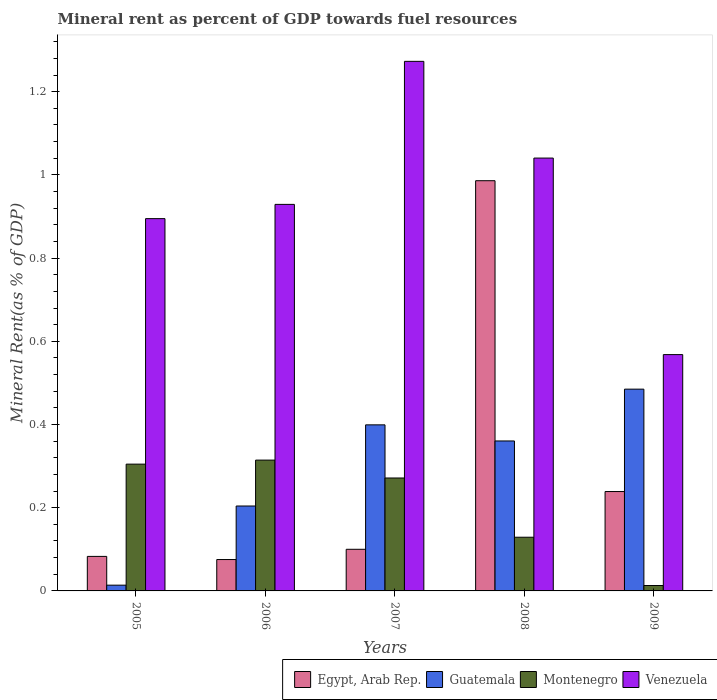How many different coloured bars are there?
Offer a very short reply. 4. Are the number of bars per tick equal to the number of legend labels?
Your answer should be compact. Yes. How many bars are there on the 2nd tick from the left?
Your answer should be very brief. 4. How many bars are there on the 3rd tick from the right?
Your response must be concise. 4. In how many cases, is the number of bars for a given year not equal to the number of legend labels?
Offer a very short reply. 0. What is the mineral rent in Guatemala in 2005?
Your answer should be compact. 0.01. Across all years, what is the maximum mineral rent in Egypt, Arab Rep.?
Ensure brevity in your answer.  0.99. Across all years, what is the minimum mineral rent in Egypt, Arab Rep.?
Provide a succinct answer. 0.08. In which year was the mineral rent in Egypt, Arab Rep. maximum?
Your response must be concise. 2008. What is the total mineral rent in Venezuela in the graph?
Ensure brevity in your answer.  4.71. What is the difference between the mineral rent in Montenegro in 2006 and that in 2008?
Offer a terse response. 0.19. What is the difference between the mineral rent in Guatemala in 2007 and the mineral rent in Montenegro in 2005?
Offer a very short reply. 0.09. What is the average mineral rent in Egypt, Arab Rep. per year?
Your response must be concise. 0.3. In the year 2007, what is the difference between the mineral rent in Guatemala and mineral rent in Venezuela?
Make the answer very short. -0.87. In how many years, is the mineral rent in Venezuela greater than 1 %?
Provide a short and direct response. 2. What is the ratio of the mineral rent in Montenegro in 2008 to that in 2009?
Ensure brevity in your answer.  9.93. Is the mineral rent in Venezuela in 2007 less than that in 2008?
Offer a terse response. No. What is the difference between the highest and the second highest mineral rent in Egypt, Arab Rep.?
Keep it short and to the point. 0.75. What is the difference between the highest and the lowest mineral rent in Montenegro?
Give a very brief answer. 0.3. Is the sum of the mineral rent in Egypt, Arab Rep. in 2007 and 2009 greater than the maximum mineral rent in Montenegro across all years?
Your response must be concise. Yes. What does the 2nd bar from the left in 2008 represents?
Provide a short and direct response. Guatemala. What does the 1st bar from the right in 2005 represents?
Ensure brevity in your answer.  Venezuela. Is it the case that in every year, the sum of the mineral rent in Montenegro and mineral rent in Venezuela is greater than the mineral rent in Guatemala?
Offer a terse response. Yes. How many bars are there?
Offer a terse response. 20. Are all the bars in the graph horizontal?
Offer a very short reply. No. What is the difference between two consecutive major ticks on the Y-axis?
Provide a short and direct response. 0.2. Does the graph contain grids?
Offer a terse response. No. How many legend labels are there?
Your answer should be very brief. 4. How are the legend labels stacked?
Give a very brief answer. Horizontal. What is the title of the graph?
Your answer should be very brief. Mineral rent as percent of GDP towards fuel resources. Does "Sub-Saharan Africa (all income levels)" appear as one of the legend labels in the graph?
Your answer should be very brief. No. What is the label or title of the X-axis?
Keep it short and to the point. Years. What is the label or title of the Y-axis?
Make the answer very short. Mineral Rent(as % of GDP). What is the Mineral Rent(as % of GDP) of Egypt, Arab Rep. in 2005?
Provide a succinct answer. 0.08. What is the Mineral Rent(as % of GDP) in Guatemala in 2005?
Offer a very short reply. 0.01. What is the Mineral Rent(as % of GDP) of Montenegro in 2005?
Keep it short and to the point. 0.3. What is the Mineral Rent(as % of GDP) of Venezuela in 2005?
Your answer should be compact. 0.89. What is the Mineral Rent(as % of GDP) of Egypt, Arab Rep. in 2006?
Your answer should be very brief. 0.08. What is the Mineral Rent(as % of GDP) of Guatemala in 2006?
Your response must be concise. 0.2. What is the Mineral Rent(as % of GDP) of Montenegro in 2006?
Provide a short and direct response. 0.31. What is the Mineral Rent(as % of GDP) of Venezuela in 2006?
Provide a succinct answer. 0.93. What is the Mineral Rent(as % of GDP) of Egypt, Arab Rep. in 2007?
Make the answer very short. 0.1. What is the Mineral Rent(as % of GDP) in Guatemala in 2007?
Provide a succinct answer. 0.4. What is the Mineral Rent(as % of GDP) in Montenegro in 2007?
Your response must be concise. 0.27. What is the Mineral Rent(as % of GDP) in Venezuela in 2007?
Make the answer very short. 1.27. What is the Mineral Rent(as % of GDP) in Egypt, Arab Rep. in 2008?
Ensure brevity in your answer.  0.99. What is the Mineral Rent(as % of GDP) in Guatemala in 2008?
Provide a short and direct response. 0.36. What is the Mineral Rent(as % of GDP) of Montenegro in 2008?
Give a very brief answer. 0.13. What is the Mineral Rent(as % of GDP) of Venezuela in 2008?
Offer a very short reply. 1.04. What is the Mineral Rent(as % of GDP) in Egypt, Arab Rep. in 2009?
Your answer should be very brief. 0.24. What is the Mineral Rent(as % of GDP) of Guatemala in 2009?
Offer a terse response. 0.48. What is the Mineral Rent(as % of GDP) in Montenegro in 2009?
Your answer should be compact. 0.01. What is the Mineral Rent(as % of GDP) of Venezuela in 2009?
Offer a terse response. 0.57. Across all years, what is the maximum Mineral Rent(as % of GDP) in Egypt, Arab Rep.?
Offer a terse response. 0.99. Across all years, what is the maximum Mineral Rent(as % of GDP) of Guatemala?
Make the answer very short. 0.48. Across all years, what is the maximum Mineral Rent(as % of GDP) in Montenegro?
Provide a succinct answer. 0.31. Across all years, what is the maximum Mineral Rent(as % of GDP) in Venezuela?
Provide a succinct answer. 1.27. Across all years, what is the minimum Mineral Rent(as % of GDP) of Egypt, Arab Rep.?
Give a very brief answer. 0.08. Across all years, what is the minimum Mineral Rent(as % of GDP) of Guatemala?
Offer a very short reply. 0.01. Across all years, what is the minimum Mineral Rent(as % of GDP) of Montenegro?
Make the answer very short. 0.01. Across all years, what is the minimum Mineral Rent(as % of GDP) in Venezuela?
Ensure brevity in your answer.  0.57. What is the total Mineral Rent(as % of GDP) in Egypt, Arab Rep. in the graph?
Make the answer very short. 1.48. What is the total Mineral Rent(as % of GDP) in Guatemala in the graph?
Provide a short and direct response. 1.46. What is the total Mineral Rent(as % of GDP) of Montenegro in the graph?
Your response must be concise. 1.03. What is the total Mineral Rent(as % of GDP) of Venezuela in the graph?
Provide a short and direct response. 4.71. What is the difference between the Mineral Rent(as % of GDP) in Egypt, Arab Rep. in 2005 and that in 2006?
Provide a short and direct response. 0.01. What is the difference between the Mineral Rent(as % of GDP) in Guatemala in 2005 and that in 2006?
Ensure brevity in your answer.  -0.19. What is the difference between the Mineral Rent(as % of GDP) of Montenegro in 2005 and that in 2006?
Offer a terse response. -0.01. What is the difference between the Mineral Rent(as % of GDP) in Venezuela in 2005 and that in 2006?
Provide a succinct answer. -0.03. What is the difference between the Mineral Rent(as % of GDP) in Egypt, Arab Rep. in 2005 and that in 2007?
Keep it short and to the point. -0.02. What is the difference between the Mineral Rent(as % of GDP) of Guatemala in 2005 and that in 2007?
Offer a very short reply. -0.39. What is the difference between the Mineral Rent(as % of GDP) of Montenegro in 2005 and that in 2007?
Ensure brevity in your answer.  0.03. What is the difference between the Mineral Rent(as % of GDP) of Venezuela in 2005 and that in 2007?
Provide a short and direct response. -0.38. What is the difference between the Mineral Rent(as % of GDP) in Egypt, Arab Rep. in 2005 and that in 2008?
Provide a succinct answer. -0.9. What is the difference between the Mineral Rent(as % of GDP) in Guatemala in 2005 and that in 2008?
Your answer should be very brief. -0.35. What is the difference between the Mineral Rent(as % of GDP) of Montenegro in 2005 and that in 2008?
Make the answer very short. 0.18. What is the difference between the Mineral Rent(as % of GDP) in Venezuela in 2005 and that in 2008?
Provide a short and direct response. -0.15. What is the difference between the Mineral Rent(as % of GDP) in Egypt, Arab Rep. in 2005 and that in 2009?
Your answer should be very brief. -0.16. What is the difference between the Mineral Rent(as % of GDP) in Guatemala in 2005 and that in 2009?
Offer a terse response. -0.47. What is the difference between the Mineral Rent(as % of GDP) of Montenegro in 2005 and that in 2009?
Make the answer very short. 0.29. What is the difference between the Mineral Rent(as % of GDP) of Venezuela in 2005 and that in 2009?
Provide a succinct answer. 0.33. What is the difference between the Mineral Rent(as % of GDP) of Egypt, Arab Rep. in 2006 and that in 2007?
Keep it short and to the point. -0.02. What is the difference between the Mineral Rent(as % of GDP) of Guatemala in 2006 and that in 2007?
Offer a very short reply. -0.2. What is the difference between the Mineral Rent(as % of GDP) in Montenegro in 2006 and that in 2007?
Offer a very short reply. 0.04. What is the difference between the Mineral Rent(as % of GDP) of Venezuela in 2006 and that in 2007?
Provide a succinct answer. -0.34. What is the difference between the Mineral Rent(as % of GDP) in Egypt, Arab Rep. in 2006 and that in 2008?
Provide a short and direct response. -0.91. What is the difference between the Mineral Rent(as % of GDP) of Guatemala in 2006 and that in 2008?
Your answer should be compact. -0.16. What is the difference between the Mineral Rent(as % of GDP) of Montenegro in 2006 and that in 2008?
Your response must be concise. 0.19. What is the difference between the Mineral Rent(as % of GDP) in Venezuela in 2006 and that in 2008?
Ensure brevity in your answer.  -0.11. What is the difference between the Mineral Rent(as % of GDP) of Egypt, Arab Rep. in 2006 and that in 2009?
Your answer should be very brief. -0.16. What is the difference between the Mineral Rent(as % of GDP) in Guatemala in 2006 and that in 2009?
Ensure brevity in your answer.  -0.28. What is the difference between the Mineral Rent(as % of GDP) in Montenegro in 2006 and that in 2009?
Your answer should be compact. 0.3. What is the difference between the Mineral Rent(as % of GDP) in Venezuela in 2006 and that in 2009?
Keep it short and to the point. 0.36. What is the difference between the Mineral Rent(as % of GDP) of Egypt, Arab Rep. in 2007 and that in 2008?
Your answer should be compact. -0.89. What is the difference between the Mineral Rent(as % of GDP) in Guatemala in 2007 and that in 2008?
Provide a succinct answer. 0.04. What is the difference between the Mineral Rent(as % of GDP) of Montenegro in 2007 and that in 2008?
Your answer should be compact. 0.14. What is the difference between the Mineral Rent(as % of GDP) in Venezuela in 2007 and that in 2008?
Keep it short and to the point. 0.23. What is the difference between the Mineral Rent(as % of GDP) of Egypt, Arab Rep. in 2007 and that in 2009?
Offer a terse response. -0.14. What is the difference between the Mineral Rent(as % of GDP) of Guatemala in 2007 and that in 2009?
Offer a terse response. -0.09. What is the difference between the Mineral Rent(as % of GDP) in Montenegro in 2007 and that in 2009?
Your response must be concise. 0.26. What is the difference between the Mineral Rent(as % of GDP) of Venezuela in 2007 and that in 2009?
Ensure brevity in your answer.  0.7. What is the difference between the Mineral Rent(as % of GDP) in Egypt, Arab Rep. in 2008 and that in 2009?
Your response must be concise. 0.75. What is the difference between the Mineral Rent(as % of GDP) of Guatemala in 2008 and that in 2009?
Your answer should be compact. -0.12. What is the difference between the Mineral Rent(as % of GDP) in Montenegro in 2008 and that in 2009?
Your answer should be very brief. 0.12. What is the difference between the Mineral Rent(as % of GDP) in Venezuela in 2008 and that in 2009?
Offer a terse response. 0.47. What is the difference between the Mineral Rent(as % of GDP) of Egypt, Arab Rep. in 2005 and the Mineral Rent(as % of GDP) of Guatemala in 2006?
Offer a very short reply. -0.12. What is the difference between the Mineral Rent(as % of GDP) in Egypt, Arab Rep. in 2005 and the Mineral Rent(as % of GDP) in Montenegro in 2006?
Make the answer very short. -0.23. What is the difference between the Mineral Rent(as % of GDP) of Egypt, Arab Rep. in 2005 and the Mineral Rent(as % of GDP) of Venezuela in 2006?
Provide a short and direct response. -0.85. What is the difference between the Mineral Rent(as % of GDP) in Guatemala in 2005 and the Mineral Rent(as % of GDP) in Montenegro in 2006?
Keep it short and to the point. -0.3. What is the difference between the Mineral Rent(as % of GDP) in Guatemala in 2005 and the Mineral Rent(as % of GDP) in Venezuela in 2006?
Offer a very short reply. -0.92. What is the difference between the Mineral Rent(as % of GDP) in Montenegro in 2005 and the Mineral Rent(as % of GDP) in Venezuela in 2006?
Your answer should be very brief. -0.62. What is the difference between the Mineral Rent(as % of GDP) of Egypt, Arab Rep. in 2005 and the Mineral Rent(as % of GDP) of Guatemala in 2007?
Your response must be concise. -0.32. What is the difference between the Mineral Rent(as % of GDP) in Egypt, Arab Rep. in 2005 and the Mineral Rent(as % of GDP) in Montenegro in 2007?
Provide a succinct answer. -0.19. What is the difference between the Mineral Rent(as % of GDP) of Egypt, Arab Rep. in 2005 and the Mineral Rent(as % of GDP) of Venezuela in 2007?
Your answer should be very brief. -1.19. What is the difference between the Mineral Rent(as % of GDP) of Guatemala in 2005 and the Mineral Rent(as % of GDP) of Montenegro in 2007?
Your response must be concise. -0.26. What is the difference between the Mineral Rent(as % of GDP) of Guatemala in 2005 and the Mineral Rent(as % of GDP) of Venezuela in 2007?
Provide a succinct answer. -1.26. What is the difference between the Mineral Rent(as % of GDP) in Montenegro in 2005 and the Mineral Rent(as % of GDP) in Venezuela in 2007?
Make the answer very short. -0.97. What is the difference between the Mineral Rent(as % of GDP) of Egypt, Arab Rep. in 2005 and the Mineral Rent(as % of GDP) of Guatemala in 2008?
Keep it short and to the point. -0.28. What is the difference between the Mineral Rent(as % of GDP) in Egypt, Arab Rep. in 2005 and the Mineral Rent(as % of GDP) in Montenegro in 2008?
Your response must be concise. -0.05. What is the difference between the Mineral Rent(as % of GDP) in Egypt, Arab Rep. in 2005 and the Mineral Rent(as % of GDP) in Venezuela in 2008?
Your response must be concise. -0.96. What is the difference between the Mineral Rent(as % of GDP) in Guatemala in 2005 and the Mineral Rent(as % of GDP) in Montenegro in 2008?
Provide a succinct answer. -0.12. What is the difference between the Mineral Rent(as % of GDP) in Guatemala in 2005 and the Mineral Rent(as % of GDP) in Venezuela in 2008?
Offer a very short reply. -1.03. What is the difference between the Mineral Rent(as % of GDP) of Montenegro in 2005 and the Mineral Rent(as % of GDP) of Venezuela in 2008?
Give a very brief answer. -0.74. What is the difference between the Mineral Rent(as % of GDP) in Egypt, Arab Rep. in 2005 and the Mineral Rent(as % of GDP) in Guatemala in 2009?
Offer a very short reply. -0.4. What is the difference between the Mineral Rent(as % of GDP) in Egypt, Arab Rep. in 2005 and the Mineral Rent(as % of GDP) in Montenegro in 2009?
Keep it short and to the point. 0.07. What is the difference between the Mineral Rent(as % of GDP) of Egypt, Arab Rep. in 2005 and the Mineral Rent(as % of GDP) of Venezuela in 2009?
Ensure brevity in your answer.  -0.48. What is the difference between the Mineral Rent(as % of GDP) in Guatemala in 2005 and the Mineral Rent(as % of GDP) in Montenegro in 2009?
Make the answer very short. 0. What is the difference between the Mineral Rent(as % of GDP) in Guatemala in 2005 and the Mineral Rent(as % of GDP) in Venezuela in 2009?
Keep it short and to the point. -0.55. What is the difference between the Mineral Rent(as % of GDP) of Montenegro in 2005 and the Mineral Rent(as % of GDP) of Venezuela in 2009?
Give a very brief answer. -0.26. What is the difference between the Mineral Rent(as % of GDP) of Egypt, Arab Rep. in 2006 and the Mineral Rent(as % of GDP) of Guatemala in 2007?
Provide a short and direct response. -0.32. What is the difference between the Mineral Rent(as % of GDP) in Egypt, Arab Rep. in 2006 and the Mineral Rent(as % of GDP) in Montenegro in 2007?
Make the answer very short. -0.2. What is the difference between the Mineral Rent(as % of GDP) in Egypt, Arab Rep. in 2006 and the Mineral Rent(as % of GDP) in Venezuela in 2007?
Offer a very short reply. -1.2. What is the difference between the Mineral Rent(as % of GDP) in Guatemala in 2006 and the Mineral Rent(as % of GDP) in Montenegro in 2007?
Keep it short and to the point. -0.07. What is the difference between the Mineral Rent(as % of GDP) of Guatemala in 2006 and the Mineral Rent(as % of GDP) of Venezuela in 2007?
Offer a terse response. -1.07. What is the difference between the Mineral Rent(as % of GDP) in Montenegro in 2006 and the Mineral Rent(as % of GDP) in Venezuela in 2007?
Your response must be concise. -0.96. What is the difference between the Mineral Rent(as % of GDP) in Egypt, Arab Rep. in 2006 and the Mineral Rent(as % of GDP) in Guatemala in 2008?
Your answer should be very brief. -0.28. What is the difference between the Mineral Rent(as % of GDP) in Egypt, Arab Rep. in 2006 and the Mineral Rent(as % of GDP) in Montenegro in 2008?
Make the answer very short. -0.05. What is the difference between the Mineral Rent(as % of GDP) of Egypt, Arab Rep. in 2006 and the Mineral Rent(as % of GDP) of Venezuela in 2008?
Provide a short and direct response. -0.96. What is the difference between the Mineral Rent(as % of GDP) of Guatemala in 2006 and the Mineral Rent(as % of GDP) of Montenegro in 2008?
Your answer should be very brief. 0.07. What is the difference between the Mineral Rent(as % of GDP) of Guatemala in 2006 and the Mineral Rent(as % of GDP) of Venezuela in 2008?
Provide a succinct answer. -0.84. What is the difference between the Mineral Rent(as % of GDP) in Montenegro in 2006 and the Mineral Rent(as % of GDP) in Venezuela in 2008?
Provide a short and direct response. -0.73. What is the difference between the Mineral Rent(as % of GDP) of Egypt, Arab Rep. in 2006 and the Mineral Rent(as % of GDP) of Guatemala in 2009?
Provide a short and direct response. -0.41. What is the difference between the Mineral Rent(as % of GDP) of Egypt, Arab Rep. in 2006 and the Mineral Rent(as % of GDP) of Montenegro in 2009?
Keep it short and to the point. 0.06. What is the difference between the Mineral Rent(as % of GDP) of Egypt, Arab Rep. in 2006 and the Mineral Rent(as % of GDP) of Venezuela in 2009?
Your answer should be compact. -0.49. What is the difference between the Mineral Rent(as % of GDP) in Guatemala in 2006 and the Mineral Rent(as % of GDP) in Montenegro in 2009?
Provide a short and direct response. 0.19. What is the difference between the Mineral Rent(as % of GDP) in Guatemala in 2006 and the Mineral Rent(as % of GDP) in Venezuela in 2009?
Make the answer very short. -0.36. What is the difference between the Mineral Rent(as % of GDP) of Montenegro in 2006 and the Mineral Rent(as % of GDP) of Venezuela in 2009?
Ensure brevity in your answer.  -0.25. What is the difference between the Mineral Rent(as % of GDP) in Egypt, Arab Rep. in 2007 and the Mineral Rent(as % of GDP) in Guatemala in 2008?
Your answer should be very brief. -0.26. What is the difference between the Mineral Rent(as % of GDP) in Egypt, Arab Rep. in 2007 and the Mineral Rent(as % of GDP) in Montenegro in 2008?
Keep it short and to the point. -0.03. What is the difference between the Mineral Rent(as % of GDP) of Egypt, Arab Rep. in 2007 and the Mineral Rent(as % of GDP) of Venezuela in 2008?
Give a very brief answer. -0.94. What is the difference between the Mineral Rent(as % of GDP) in Guatemala in 2007 and the Mineral Rent(as % of GDP) in Montenegro in 2008?
Ensure brevity in your answer.  0.27. What is the difference between the Mineral Rent(as % of GDP) of Guatemala in 2007 and the Mineral Rent(as % of GDP) of Venezuela in 2008?
Offer a terse response. -0.64. What is the difference between the Mineral Rent(as % of GDP) of Montenegro in 2007 and the Mineral Rent(as % of GDP) of Venezuela in 2008?
Your answer should be very brief. -0.77. What is the difference between the Mineral Rent(as % of GDP) of Egypt, Arab Rep. in 2007 and the Mineral Rent(as % of GDP) of Guatemala in 2009?
Give a very brief answer. -0.38. What is the difference between the Mineral Rent(as % of GDP) of Egypt, Arab Rep. in 2007 and the Mineral Rent(as % of GDP) of Montenegro in 2009?
Make the answer very short. 0.09. What is the difference between the Mineral Rent(as % of GDP) in Egypt, Arab Rep. in 2007 and the Mineral Rent(as % of GDP) in Venezuela in 2009?
Provide a short and direct response. -0.47. What is the difference between the Mineral Rent(as % of GDP) of Guatemala in 2007 and the Mineral Rent(as % of GDP) of Montenegro in 2009?
Provide a succinct answer. 0.39. What is the difference between the Mineral Rent(as % of GDP) of Guatemala in 2007 and the Mineral Rent(as % of GDP) of Venezuela in 2009?
Make the answer very short. -0.17. What is the difference between the Mineral Rent(as % of GDP) in Montenegro in 2007 and the Mineral Rent(as % of GDP) in Venezuela in 2009?
Make the answer very short. -0.3. What is the difference between the Mineral Rent(as % of GDP) in Egypt, Arab Rep. in 2008 and the Mineral Rent(as % of GDP) in Guatemala in 2009?
Your answer should be very brief. 0.5. What is the difference between the Mineral Rent(as % of GDP) in Egypt, Arab Rep. in 2008 and the Mineral Rent(as % of GDP) in Venezuela in 2009?
Keep it short and to the point. 0.42. What is the difference between the Mineral Rent(as % of GDP) of Guatemala in 2008 and the Mineral Rent(as % of GDP) of Montenegro in 2009?
Your response must be concise. 0.35. What is the difference between the Mineral Rent(as % of GDP) of Guatemala in 2008 and the Mineral Rent(as % of GDP) of Venezuela in 2009?
Offer a terse response. -0.21. What is the difference between the Mineral Rent(as % of GDP) of Montenegro in 2008 and the Mineral Rent(as % of GDP) of Venezuela in 2009?
Provide a succinct answer. -0.44. What is the average Mineral Rent(as % of GDP) of Egypt, Arab Rep. per year?
Provide a short and direct response. 0.3. What is the average Mineral Rent(as % of GDP) in Guatemala per year?
Provide a short and direct response. 0.29. What is the average Mineral Rent(as % of GDP) in Montenegro per year?
Keep it short and to the point. 0.21. What is the average Mineral Rent(as % of GDP) in Venezuela per year?
Your answer should be very brief. 0.94. In the year 2005, what is the difference between the Mineral Rent(as % of GDP) in Egypt, Arab Rep. and Mineral Rent(as % of GDP) in Guatemala?
Keep it short and to the point. 0.07. In the year 2005, what is the difference between the Mineral Rent(as % of GDP) of Egypt, Arab Rep. and Mineral Rent(as % of GDP) of Montenegro?
Provide a succinct answer. -0.22. In the year 2005, what is the difference between the Mineral Rent(as % of GDP) of Egypt, Arab Rep. and Mineral Rent(as % of GDP) of Venezuela?
Your answer should be very brief. -0.81. In the year 2005, what is the difference between the Mineral Rent(as % of GDP) of Guatemala and Mineral Rent(as % of GDP) of Montenegro?
Provide a short and direct response. -0.29. In the year 2005, what is the difference between the Mineral Rent(as % of GDP) in Guatemala and Mineral Rent(as % of GDP) in Venezuela?
Your answer should be very brief. -0.88. In the year 2005, what is the difference between the Mineral Rent(as % of GDP) of Montenegro and Mineral Rent(as % of GDP) of Venezuela?
Your answer should be very brief. -0.59. In the year 2006, what is the difference between the Mineral Rent(as % of GDP) in Egypt, Arab Rep. and Mineral Rent(as % of GDP) in Guatemala?
Offer a terse response. -0.13. In the year 2006, what is the difference between the Mineral Rent(as % of GDP) of Egypt, Arab Rep. and Mineral Rent(as % of GDP) of Montenegro?
Offer a terse response. -0.24. In the year 2006, what is the difference between the Mineral Rent(as % of GDP) in Egypt, Arab Rep. and Mineral Rent(as % of GDP) in Venezuela?
Give a very brief answer. -0.85. In the year 2006, what is the difference between the Mineral Rent(as % of GDP) in Guatemala and Mineral Rent(as % of GDP) in Montenegro?
Ensure brevity in your answer.  -0.11. In the year 2006, what is the difference between the Mineral Rent(as % of GDP) in Guatemala and Mineral Rent(as % of GDP) in Venezuela?
Offer a very short reply. -0.72. In the year 2006, what is the difference between the Mineral Rent(as % of GDP) in Montenegro and Mineral Rent(as % of GDP) in Venezuela?
Offer a terse response. -0.61. In the year 2007, what is the difference between the Mineral Rent(as % of GDP) in Egypt, Arab Rep. and Mineral Rent(as % of GDP) in Guatemala?
Make the answer very short. -0.3. In the year 2007, what is the difference between the Mineral Rent(as % of GDP) in Egypt, Arab Rep. and Mineral Rent(as % of GDP) in Montenegro?
Make the answer very short. -0.17. In the year 2007, what is the difference between the Mineral Rent(as % of GDP) of Egypt, Arab Rep. and Mineral Rent(as % of GDP) of Venezuela?
Provide a succinct answer. -1.17. In the year 2007, what is the difference between the Mineral Rent(as % of GDP) in Guatemala and Mineral Rent(as % of GDP) in Montenegro?
Your response must be concise. 0.13. In the year 2007, what is the difference between the Mineral Rent(as % of GDP) of Guatemala and Mineral Rent(as % of GDP) of Venezuela?
Give a very brief answer. -0.87. In the year 2007, what is the difference between the Mineral Rent(as % of GDP) of Montenegro and Mineral Rent(as % of GDP) of Venezuela?
Offer a terse response. -1. In the year 2008, what is the difference between the Mineral Rent(as % of GDP) in Egypt, Arab Rep. and Mineral Rent(as % of GDP) in Guatemala?
Offer a very short reply. 0.63. In the year 2008, what is the difference between the Mineral Rent(as % of GDP) in Egypt, Arab Rep. and Mineral Rent(as % of GDP) in Montenegro?
Provide a succinct answer. 0.86. In the year 2008, what is the difference between the Mineral Rent(as % of GDP) in Egypt, Arab Rep. and Mineral Rent(as % of GDP) in Venezuela?
Provide a short and direct response. -0.05. In the year 2008, what is the difference between the Mineral Rent(as % of GDP) in Guatemala and Mineral Rent(as % of GDP) in Montenegro?
Keep it short and to the point. 0.23. In the year 2008, what is the difference between the Mineral Rent(as % of GDP) of Guatemala and Mineral Rent(as % of GDP) of Venezuela?
Provide a succinct answer. -0.68. In the year 2008, what is the difference between the Mineral Rent(as % of GDP) of Montenegro and Mineral Rent(as % of GDP) of Venezuela?
Provide a short and direct response. -0.91. In the year 2009, what is the difference between the Mineral Rent(as % of GDP) of Egypt, Arab Rep. and Mineral Rent(as % of GDP) of Guatemala?
Keep it short and to the point. -0.25. In the year 2009, what is the difference between the Mineral Rent(as % of GDP) of Egypt, Arab Rep. and Mineral Rent(as % of GDP) of Montenegro?
Your answer should be compact. 0.23. In the year 2009, what is the difference between the Mineral Rent(as % of GDP) in Egypt, Arab Rep. and Mineral Rent(as % of GDP) in Venezuela?
Make the answer very short. -0.33. In the year 2009, what is the difference between the Mineral Rent(as % of GDP) of Guatemala and Mineral Rent(as % of GDP) of Montenegro?
Ensure brevity in your answer.  0.47. In the year 2009, what is the difference between the Mineral Rent(as % of GDP) in Guatemala and Mineral Rent(as % of GDP) in Venezuela?
Ensure brevity in your answer.  -0.08. In the year 2009, what is the difference between the Mineral Rent(as % of GDP) of Montenegro and Mineral Rent(as % of GDP) of Venezuela?
Ensure brevity in your answer.  -0.56. What is the ratio of the Mineral Rent(as % of GDP) in Guatemala in 2005 to that in 2006?
Ensure brevity in your answer.  0.07. What is the ratio of the Mineral Rent(as % of GDP) in Montenegro in 2005 to that in 2006?
Give a very brief answer. 0.97. What is the ratio of the Mineral Rent(as % of GDP) in Venezuela in 2005 to that in 2006?
Provide a succinct answer. 0.96. What is the ratio of the Mineral Rent(as % of GDP) of Egypt, Arab Rep. in 2005 to that in 2007?
Ensure brevity in your answer.  0.83. What is the ratio of the Mineral Rent(as % of GDP) of Guatemala in 2005 to that in 2007?
Give a very brief answer. 0.03. What is the ratio of the Mineral Rent(as % of GDP) in Montenegro in 2005 to that in 2007?
Your answer should be compact. 1.12. What is the ratio of the Mineral Rent(as % of GDP) in Venezuela in 2005 to that in 2007?
Offer a terse response. 0.7. What is the ratio of the Mineral Rent(as % of GDP) in Egypt, Arab Rep. in 2005 to that in 2008?
Offer a terse response. 0.08. What is the ratio of the Mineral Rent(as % of GDP) of Guatemala in 2005 to that in 2008?
Your answer should be very brief. 0.04. What is the ratio of the Mineral Rent(as % of GDP) of Montenegro in 2005 to that in 2008?
Your answer should be very brief. 2.36. What is the ratio of the Mineral Rent(as % of GDP) of Venezuela in 2005 to that in 2008?
Ensure brevity in your answer.  0.86. What is the ratio of the Mineral Rent(as % of GDP) of Egypt, Arab Rep. in 2005 to that in 2009?
Provide a succinct answer. 0.35. What is the ratio of the Mineral Rent(as % of GDP) in Guatemala in 2005 to that in 2009?
Ensure brevity in your answer.  0.03. What is the ratio of the Mineral Rent(as % of GDP) in Montenegro in 2005 to that in 2009?
Your answer should be compact. 23.45. What is the ratio of the Mineral Rent(as % of GDP) of Venezuela in 2005 to that in 2009?
Provide a short and direct response. 1.58. What is the ratio of the Mineral Rent(as % of GDP) in Egypt, Arab Rep. in 2006 to that in 2007?
Your answer should be very brief. 0.75. What is the ratio of the Mineral Rent(as % of GDP) of Guatemala in 2006 to that in 2007?
Keep it short and to the point. 0.51. What is the ratio of the Mineral Rent(as % of GDP) in Montenegro in 2006 to that in 2007?
Provide a succinct answer. 1.16. What is the ratio of the Mineral Rent(as % of GDP) of Venezuela in 2006 to that in 2007?
Your answer should be very brief. 0.73. What is the ratio of the Mineral Rent(as % of GDP) in Egypt, Arab Rep. in 2006 to that in 2008?
Make the answer very short. 0.08. What is the ratio of the Mineral Rent(as % of GDP) in Guatemala in 2006 to that in 2008?
Your response must be concise. 0.57. What is the ratio of the Mineral Rent(as % of GDP) of Montenegro in 2006 to that in 2008?
Your answer should be very brief. 2.44. What is the ratio of the Mineral Rent(as % of GDP) in Venezuela in 2006 to that in 2008?
Your answer should be compact. 0.89. What is the ratio of the Mineral Rent(as % of GDP) in Egypt, Arab Rep. in 2006 to that in 2009?
Provide a succinct answer. 0.32. What is the ratio of the Mineral Rent(as % of GDP) of Guatemala in 2006 to that in 2009?
Keep it short and to the point. 0.42. What is the ratio of the Mineral Rent(as % of GDP) in Montenegro in 2006 to that in 2009?
Give a very brief answer. 24.2. What is the ratio of the Mineral Rent(as % of GDP) in Venezuela in 2006 to that in 2009?
Give a very brief answer. 1.64. What is the ratio of the Mineral Rent(as % of GDP) in Egypt, Arab Rep. in 2007 to that in 2008?
Your answer should be very brief. 0.1. What is the ratio of the Mineral Rent(as % of GDP) of Guatemala in 2007 to that in 2008?
Offer a terse response. 1.11. What is the ratio of the Mineral Rent(as % of GDP) of Montenegro in 2007 to that in 2008?
Your response must be concise. 2.1. What is the ratio of the Mineral Rent(as % of GDP) in Venezuela in 2007 to that in 2008?
Keep it short and to the point. 1.22. What is the ratio of the Mineral Rent(as % of GDP) of Egypt, Arab Rep. in 2007 to that in 2009?
Provide a short and direct response. 0.42. What is the ratio of the Mineral Rent(as % of GDP) of Guatemala in 2007 to that in 2009?
Give a very brief answer. 0.82. What is the ratio of the Mineral Rent(as % of GDP) in Montenegro in 2007 to that in 2009?
Provide a short and direct response. 20.89. What is the ratio of the Mineral Rent(as % of GDP) in Venezuela in 2007 to that in 2009?
Provide a succinct answer. 2.24. What is the ratio of the Mineral Rent(as % of GDP) in Egypt, Arab Rep. in 2008 to that in 2009?
Give a very brief answer. 4.13. What is the ratio of the Mineral Rent(as % of GDP) in Guatemala in 2008 to that in 2009?
Your answer should be very brief. 0.74. What is the ratio of the Mineral Rent(as % of GDP) in Montenegro in 2008 to that in 2009?
Give a very brief answer. 9.93. What is the ratio of the Mineral Rent(as % of GDP) of Venezuela in 2008 to that in 2009?
Offer a very short reply. 1.83. What is the difference between the highest and the second highest Mineral Rent(as % of GDP) in Egypt, Arab Rep.?
Your answer should be very brief. 0.75. What is the difference between the highest and the second highest Mineral Rent(as % of GDP) of Guatemala?
Your response must be concise. 0.09. What is the difference between the highest and the second highest Mineral Rent(as % of GDP) of Montenegro?
Your answer should be compact. 0.01. What is the difference between the highest and the second highest Mineral Rent(as % of GDP) in Venezuela?
Provide a short and direct response. 0.23. What is the difference between the highest and the lowest Mineral Rent(as % of GDP) in Egypt, Arab Rep.?
Offer a terse response. 0.91. What is the difference between the highest and the lowest Mineral Rent(as % of GDP) of Guatemala?
Your answer should be very brief. 0.47. What is the difference between the highest and the lowest Mineral Rent(as % of GDP) of Montenegro?
Your answer should be very brief. 0.3. What is the difference between the highest and the lowest Mineral Rent(as % of GDP) of Venezuela?
Provide a short and direct response. 0.7. 